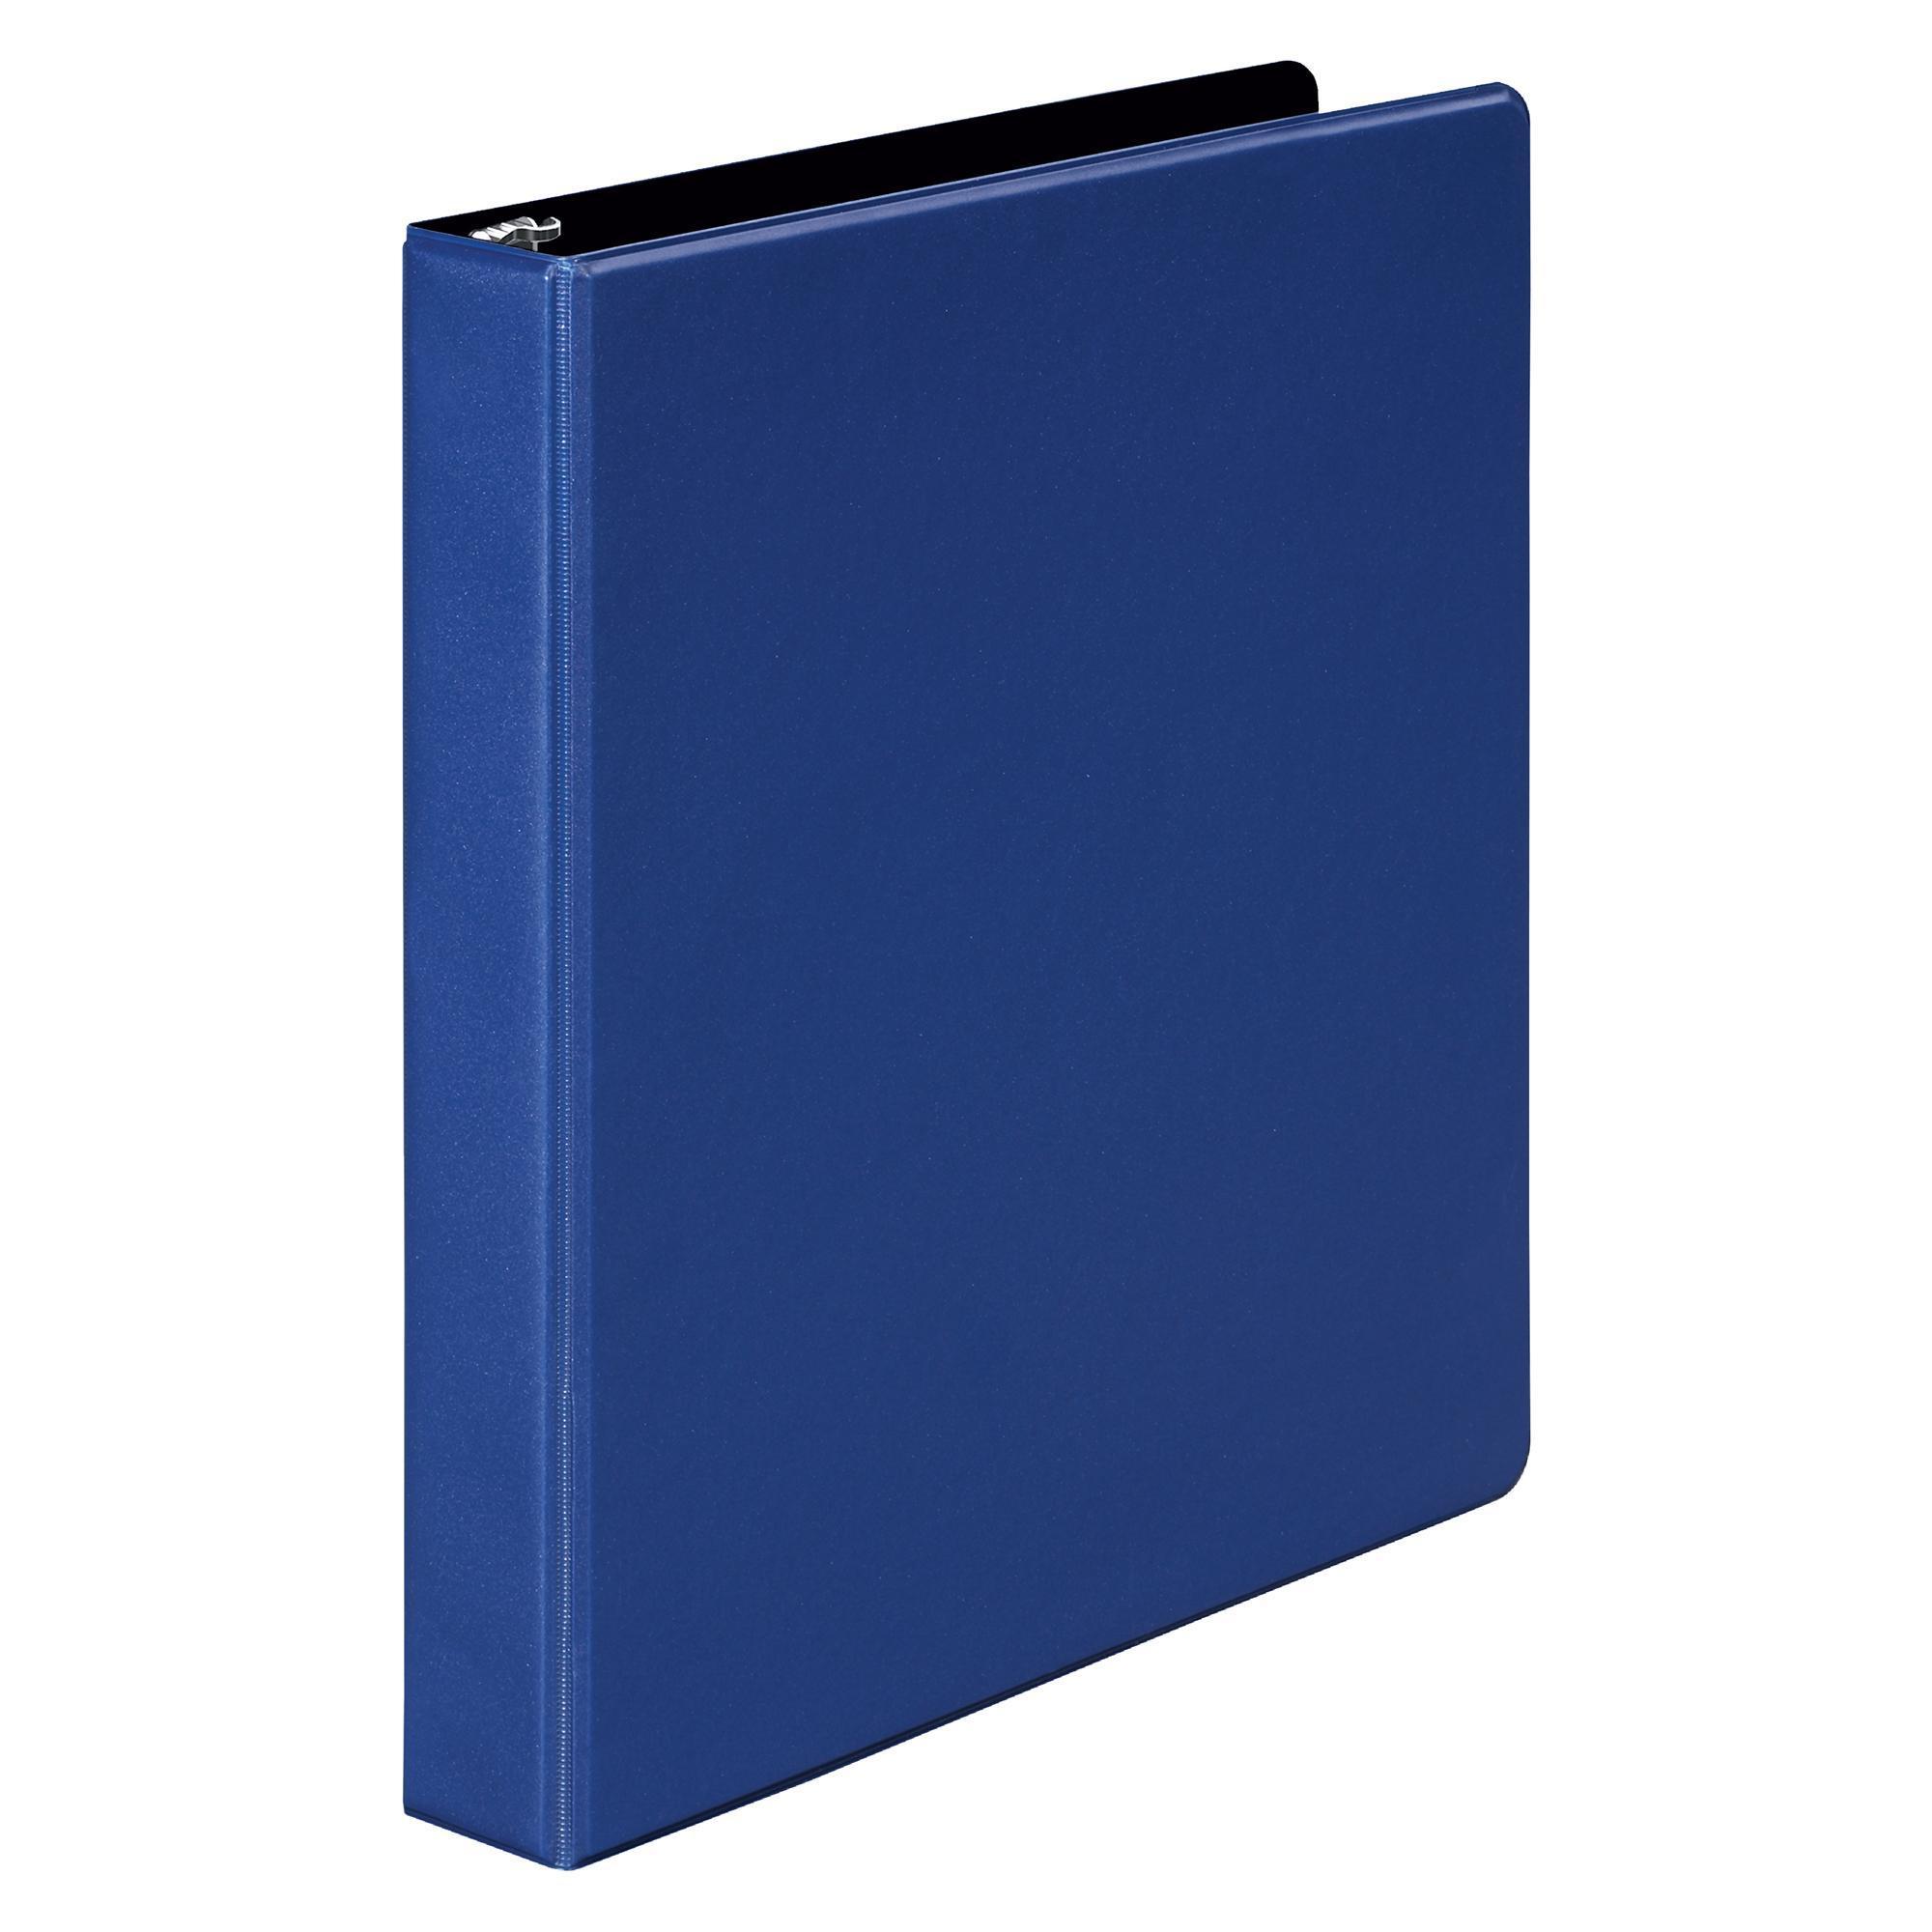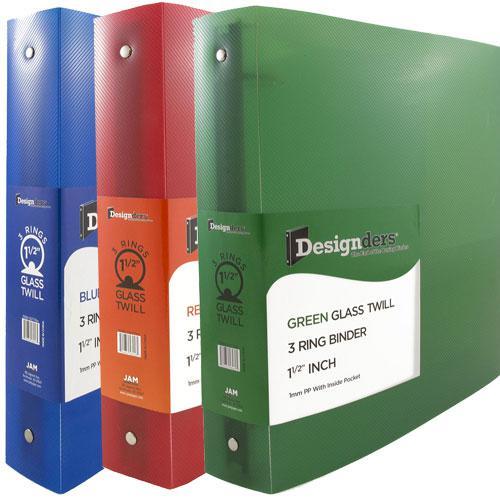The first image is the image on the left, the second image is the image on the right. Considering the images on both sides, is "An image shows multiple colored binders arranged to form a semi-circular arch." valid? Answer yes or no. No. The first image is the image on the left, the second image is the image on the right. Assess this claim about the two images: "there are no more than four binders in the image on the right". Correct or not? Answer yes or no. Yes. 